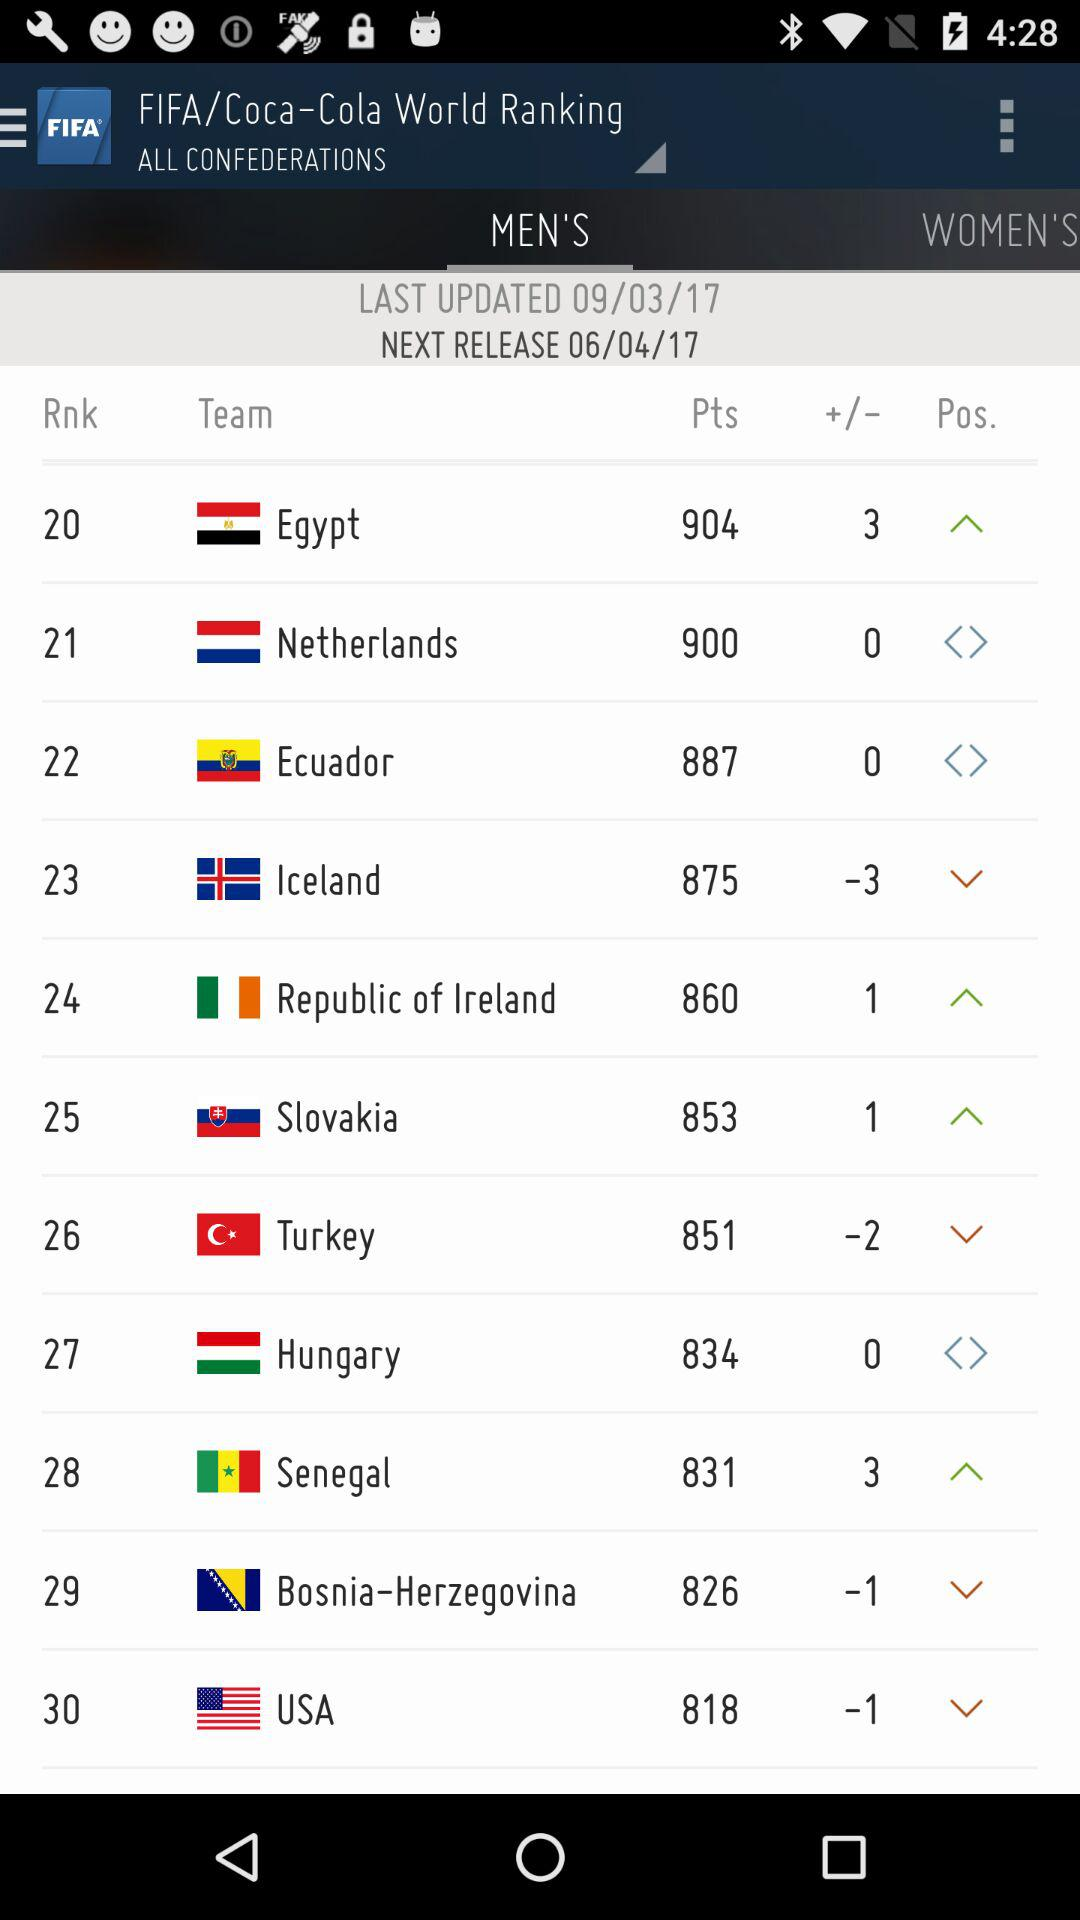What is the rank of the Egypt team? The rank of the Egypt team is 20. 